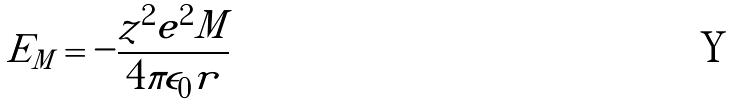Convert formula to latex. <formula><loc_0><loc_0><loc_500><loc_500>E _ { M } = - \frac { z ^ { 2 } e ^ { 2 } M } { 4 \pi \epsilon _ { 0 } r }</formula> 